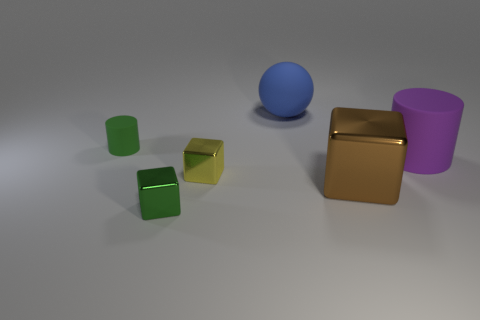What is the material of the cylinder that is to the left of the matte thing that is behind the green cylinder?
Keep it short and to the point. Rubber. What number of big things are either green things or cylinders?
Your answer should be compact. 1. The blue matte ball has what size?
Give a very brief answer. Large. Are there more blue spheres right of the big blue thing than large purple cylinders?
Provide a succinct answer. No. Are there the same number of cylinders in front of the yellow shiny cube and big blue rubber spheres that are on the right side of the large brown shiny object?
Offer a terse response. Yes. The large object that is both left of the purple object and in front of the large blue matte thing is what color?
Your response must be concise. Brown. Is there anything else that has the same size as the ball?
Give a very brief answer. Yes. Are there more brown objects on the left side of the tiny green rubber thing than large shiny things that are behind the big metallic object?
Your answer should be compact. No. There is a block that is to the right of the yellow metallic block; is it the same size as the large purple object?
Keep it short and to the point. Yes. There is a tiny green thing in front of the rubber cylinder that is right of the tiny yellow shiny thing; what number of balls are right of it?
Provide a succinct answer. 1. 